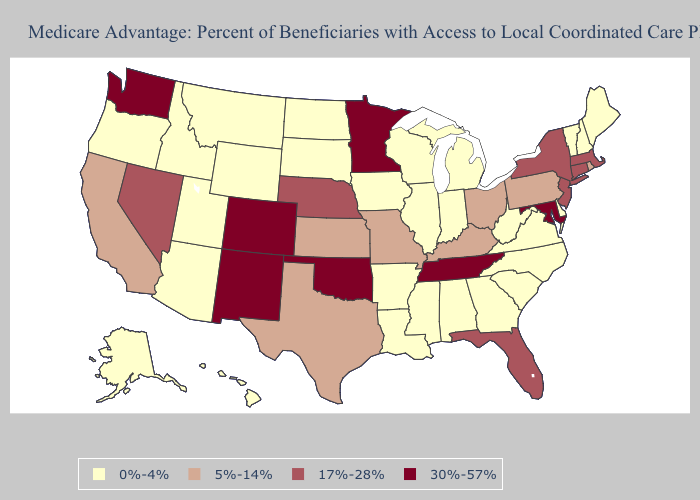Which states hav the highest value in the South?
Answer briefly. Maryland, Oklahoma, Tennessee. Which states hav the highest value in the South?
Be succinct. Maryland, Oklahoma, Tennessee. Name the states that have a value in the range 0%-4%?
Be succinct. Alaska, Alabama, Arkansas, Arizona, Delaware, Georgia, Hawaii, Iowa, Idaho, Illinois, Indiana, Louisiana, Maine, Michigan, Mississippi, Montana, North Carolina, North Dakota, New Hampshire, Oregon, South Carolina, South Dakota, Utah, Virginia, Vermont, Wisconsin, West Virginia, Wyoming. Does New York have the same value as Florida?
Be succinct. Yes. What is the value of Ohio?
Short answer required. 5%-14%. Does Minnesota have the lowest value in the USA?
Be succinct. No. Does the first symbol in the legend represent the smallest category?
Concise answer only. Yes. Does Delaware have the lowest value in the USA?
Be succinct. Yes. Does the first symbol in the legend represent the smallest category?
Short answer required. Yes. Does New York have the lowest value in the USA?
Be succinct. No. Among the states that border Ohio , does Kentucky have the lowest value?
Give a very brief answer. No. Among the states that border North Dakota , does South Dakota have the lowest value?
Answer briefly. Yes. What is the value of Montana?
Write a very short answer. 0%-4%. 